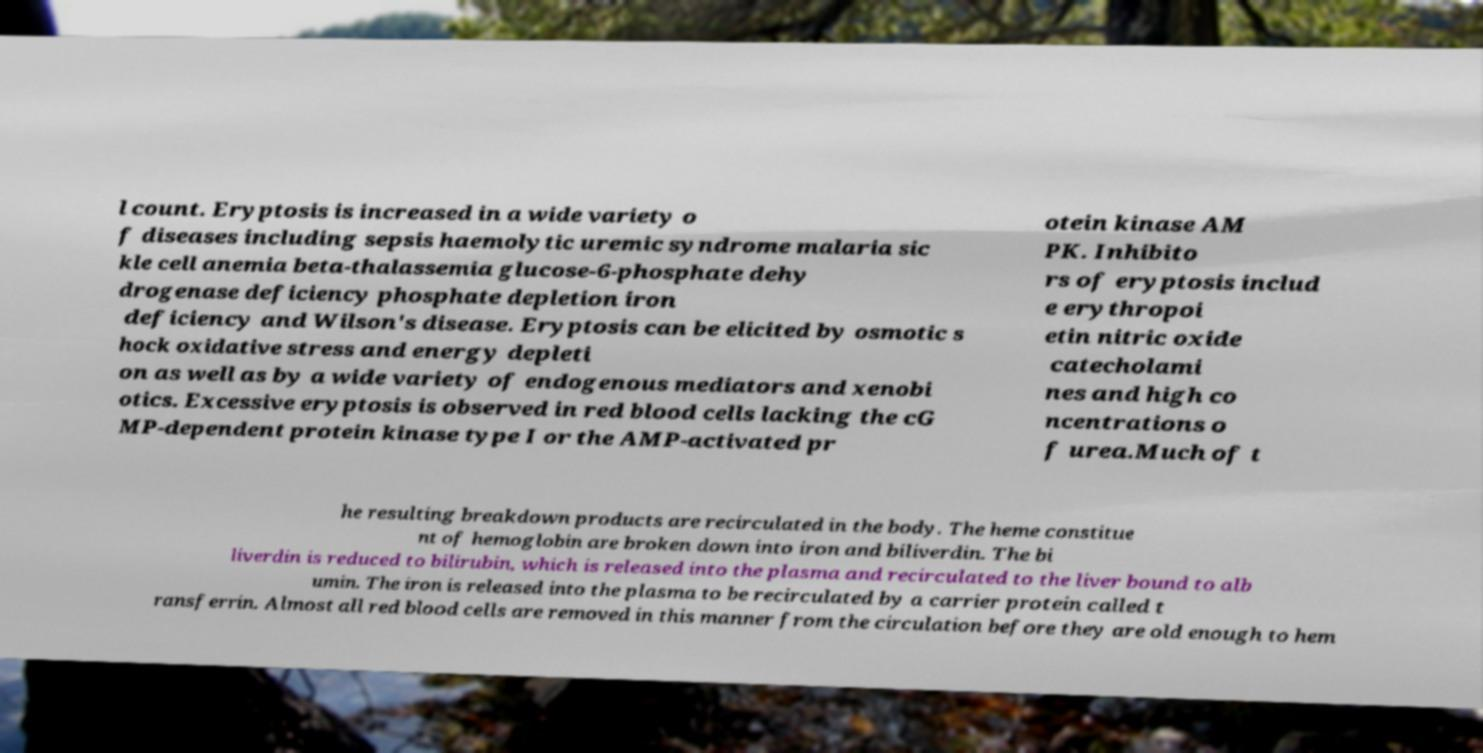For documentation purposes, I need the text within this image transcribed. Could you provide that? l count. Eryptosis is increased in a wide variety o f diseases including sepsis haemolytic uremic syndrome malaria sic kle cell anemia beta-thalassemia glucose-6-phosphate dehy drogenase deficiency phosphate depletion iron deficiency and Wilson's disease. Eryptosis can be elicited by osmotic s hock oxidative stress and energy depleti on as well as by a wide variety of endogenous mediators and xenobi otics. Excessive eryptosis is observed in red blood cells lacking the cG MP-dependent protein kinase type I or the AMP-activated pr otein kinase AM PK. Inhibito rs of eryptosis includ e erythropoi etin nitric oxide catecholami nes and high co ncentrations o f urea.Much of t he resulting breakdown products are recirculated in the body. The heme constitue nt of hemoglobin are broken down into iron and biliverdin. The bi liverdin is reduced to bilirubin, which is released into the plasma and recirculated to the liver bound to alb umin. The iron is released into the plasma to be recirculated by a carrier protein called t ransferrin. Almost all red blood cells are removed in this manner from the circulation before they are old enough to hem 